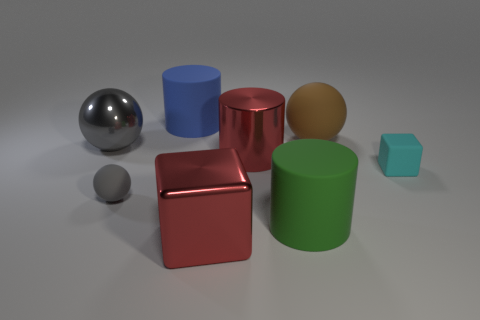Add 2 tiny purple rubber blocks. How many objects exist? 10 Subtract all cylinders. How many objects are left? 5 Add 1 gray rubber balls. How many gray rubber balls exist? 2 Subtract 0 purple balls. How many objects are left? 8 Subtract all blue cylinders. Subtract all blue matte cylinders. How many objects are left? 6 Add 5 blue rubber objects. How many blue rubber objects are left? 6 